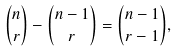<formula> <loc_0><loc_0><loc_500><loc_500>\binom { n } { r } - \binom { n - 1 } { r } = \binom { n - 1 } { r - 1 } ,</formula> 